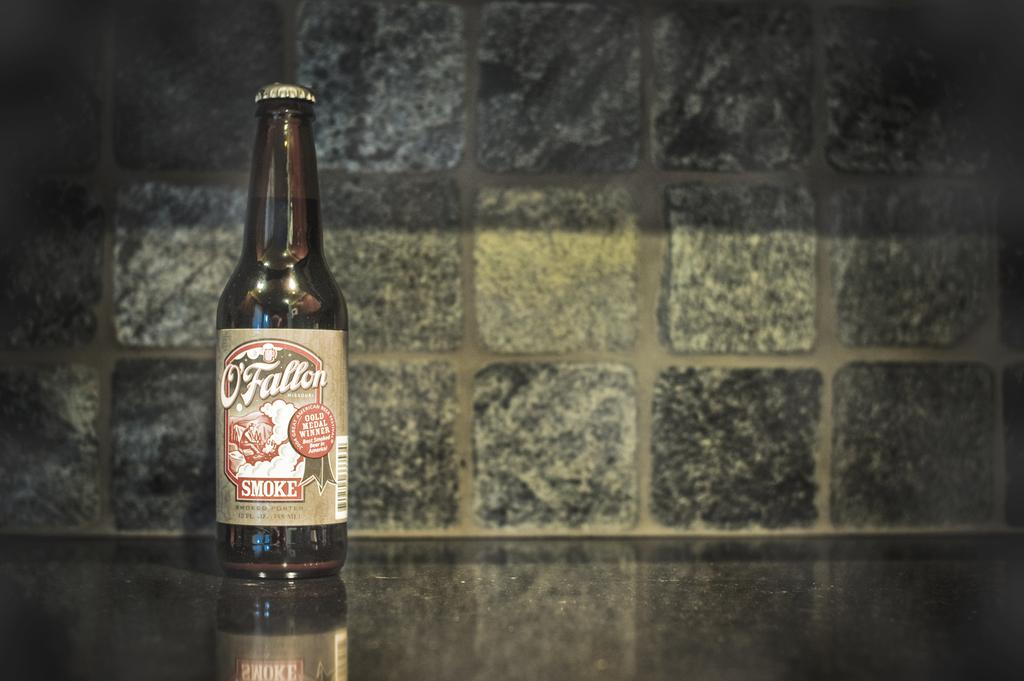<image>
Provide a brief description of the given image. A single bottle of beer is on a granite counter and says O'Fallon. 